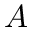<formula> <loc_0><loc_0><loc_500><loc_500>A</formula> 